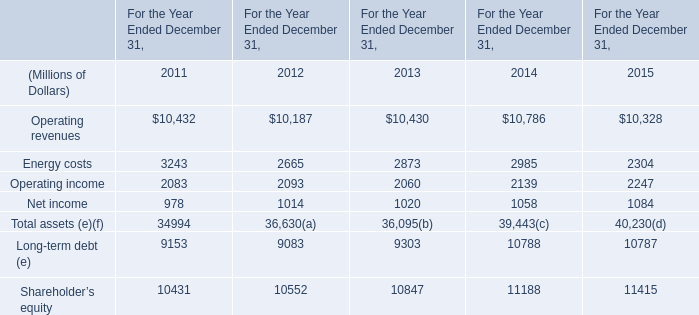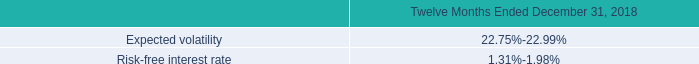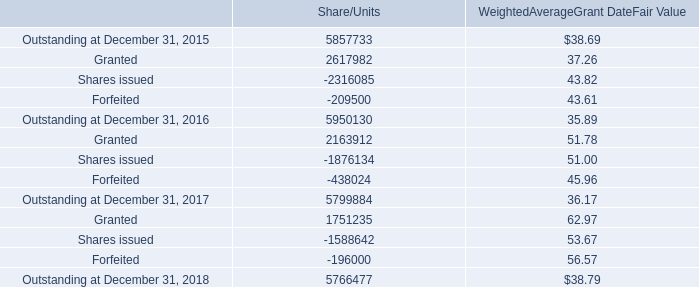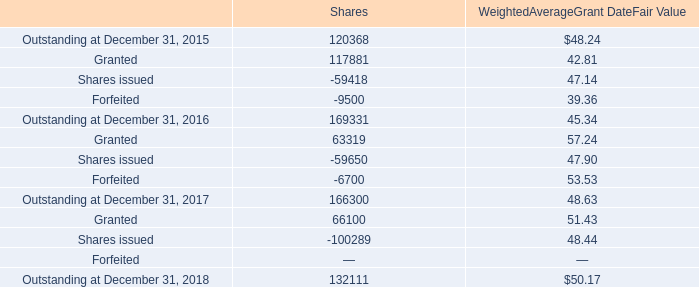What is the ratio of Operating revenues to the Shares issued for Shares in 2015? 
Computations: (10328 / -59418)
Answer: -0.17382. 